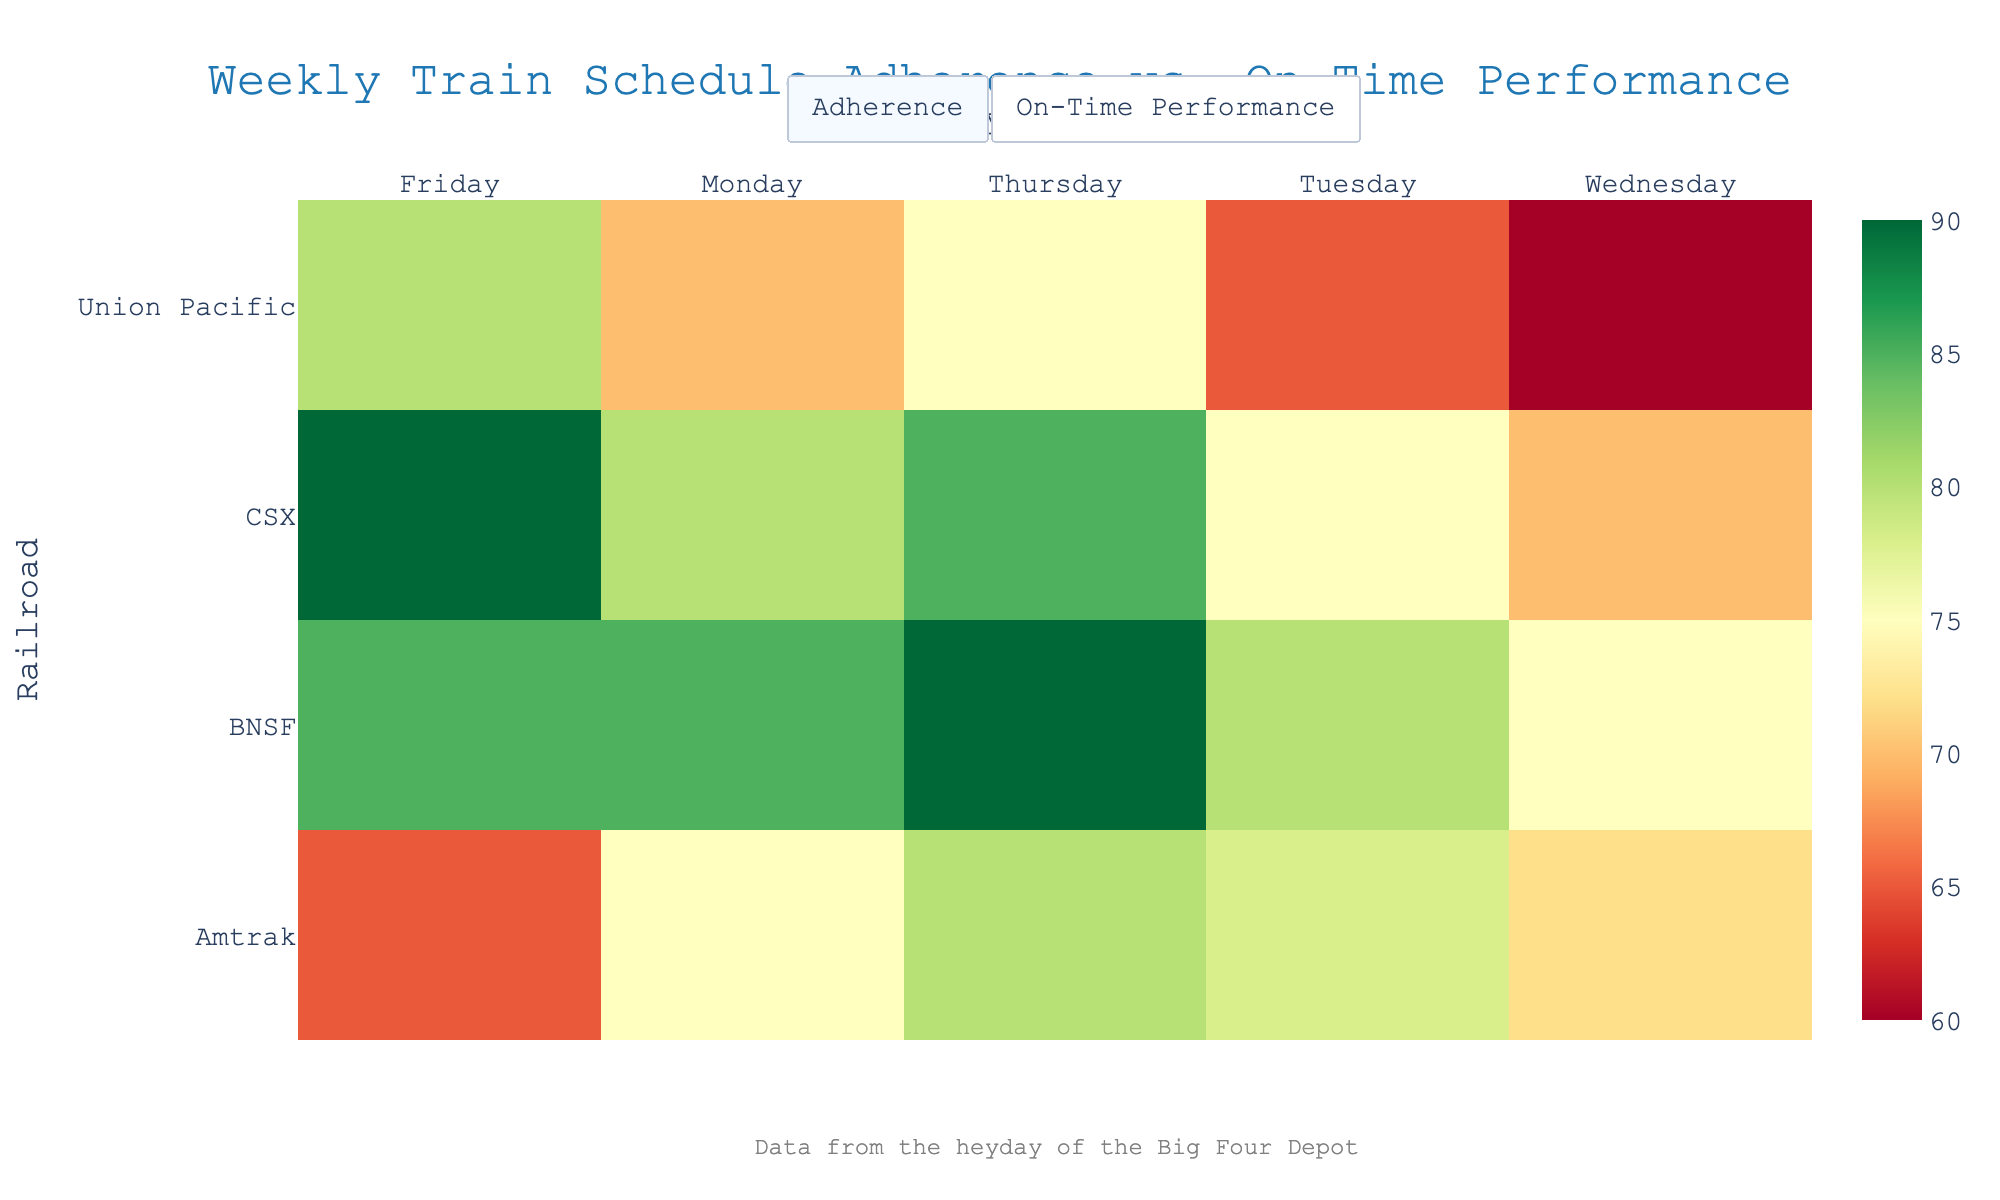What is the title of the heatmap figure? The title is located at the top of the heatmap, centered in the layout.
Answer: "Weekly Train Schedule Adherence vs. On-Time Performance" What are the two metrics visualized in the heatmap? By observing the two tabs available in the updatemenu buttons, the metrics are "Adherence Percentage" and "On-Time Performance Percentage".
Answer: Adherence Percentage and On-Time Performance Percentage Which railroad has the highest Adherence Percentage on Thursday? Switch to the "Adherence Percentage" view and find the highest value in the Thursday column for all railroads. CSX shows the highest percentage.
Answer: CSX Which day has the lowest On-Time Performance Percentage for Union Pacific? Switch to the "On-Time Performance Percentage" view. Look at the values for Union Pacific across all days and identify the day with the lowest percentage.
Answer: Wednesday What is the average Adherence Percentage for BNSF over the week? In the "Adherence Percentage" view, locate the values for BNSF, which are 85, 80, 75, 90, and 85. Calculate the average: (85 + 80 + 75 + 90 + 85)/5.
Answer: 83 Compare the Adherence Percentage and On-Time Performance Percentage for Amtrak on Tuesday. Which is higher? Compare the values on Tuesday for Amtrak in both the "Adherence Percentage" and "On-Time Performance Percentage" views. Adherence is 78%, and On-Time Performance is 85%.
Answer: On-Time Performance Which railroad provides the most consistent Adherence Percentage across the week? Switch to the "Adherence Percentage" view. Calculate or visually assess the standard deviation of adherence percentages for each railroad. BNSF and CSX show relatively similar values across the days, but CSX has fewer fluctuations.
Answer: CSX What is the difference between the highest and lowest On-Time Performance Percentage for Amtrak? In the "On-Time Performance Percentage" view, identify the highest (90%) and lowest (60%) values for Amtrak. Calculate the difference: 90 - 60.
Answer: 30 Is there any day where all railroads have an On-Time Performance Percentage above 80%? Switch to the "On-Time Performance Percentage" view and check each day column to see if all values are above 80%. No day shows all values above 80%.
Answer: No 